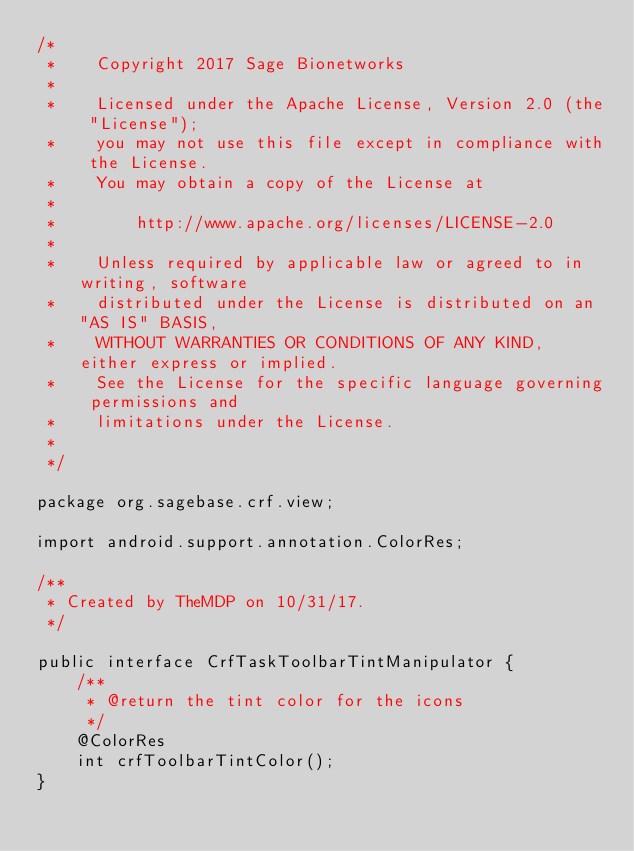Convert code to text. <code><loc_0><loc_0><loc_500><loc_500><_Java_>/*
 *    Copyright 2017 Sage Bionetworks
 *
 *    Licensed under the Apache License, Version 2.0 (the "License");
 *    you may not use this file except in compliance with the License.
 *    You may obtain a copy of the License at
 *
 *        http://www.apache.org/licenses/LICENSE-2.0
 *
 *    Unless required by applicable law or agreed to in writing, software
 *    distributed under the License is distributed on an "AS IS" BASIS,
 *    WITHOUT WARRANTIES OR CONDITIONS OF ANY KIND, either express or implied.
 *    See the License for the specific language governing permissions and
 *    limitations under the License.
 *
 */

package org.sagebase.crf.view;

import android.support.annotation.ColorRes;

/**
 * Created by TheMDP on 10/31/17.
 */

public interface CrfTaskToolbarTintManipulator {
    /**
     * @return the tint color for the icons
     */
    @ColorRes
    int crfToolbarTintColor();
}
</code> 